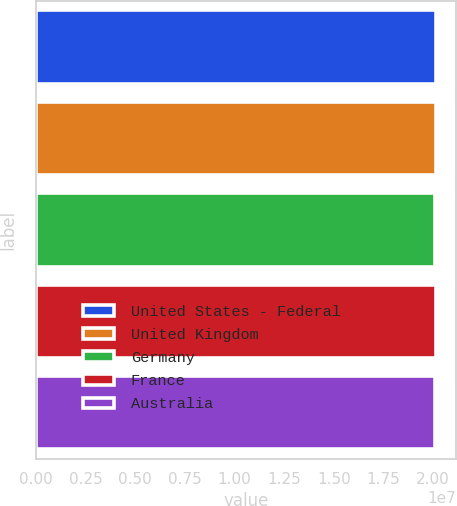Convert chart. <chart><loc_0><loc_0><loc_500><loc_500><bar_chart><fcel>United States - Federal<fcel>United Kingdom<fcel>Germany<fcel>France<fcel>Australia<nl><fcel>2.0122e+07<fcel>2.0126e+07<fcel>2.0092e+07<fcel>2.0132e+07<fcel>2.0112e+07<nl></chart> 